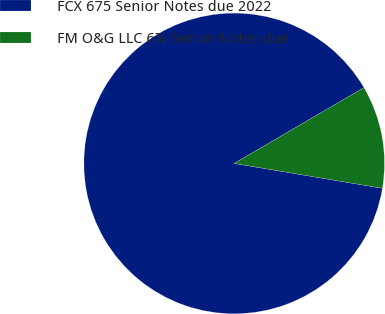<chart> <loc_0><loc_0><loc_500><loc_500><pie_chart><fcel>FCX 675 Senior Notes due 2022<fcel>FM O&G LLC 6⅞ Senior Notes due<nl><fcel>88.94%<fcel>11.06%<nl></chart> 